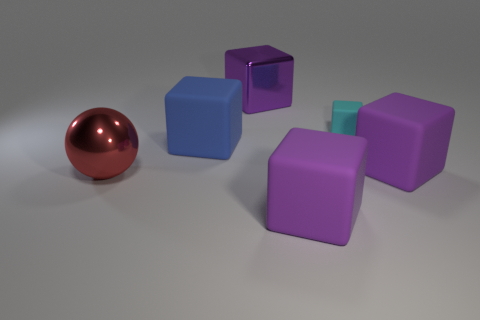Is there any other thing that has the same size as the cyan cube?
Keep it short and to the point. No. What number of yellow things are large shiny things or big rubber objects?
Offer a very short reply. 0. How many other things are the same size as the red thing?
Provide a short and direct response. 4. Are the big cube to the left of the purple shiny thing and the ball made of the same material?
Provide a succinct answer. No. Is there a purple metallic cube that is behind the matte block to the right of the cyan rubber thing?
Your answer should be very brief. Yes. Are there more small matte cubes that are on the right side of the red object than big blue blocks that are behind the tiny cyan block?
Your answer should be compact. Yes. There is a tiny thing that is made of the same material as the big blue object; what is its shape?
Your answer should be compact. Cube. Are there more tiny things in front of the red sphere than shiny blocks?
Keep it short and to the point. No. What number of large things have the same color as the shiny block?
Provide a succinct answer. 2. What number of other things are the same color as the shiny block?
Keep it short and to the point. 2. 